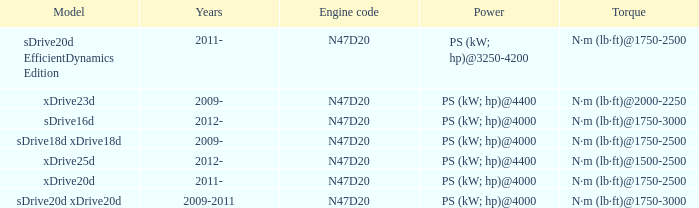What is the engine code of the xdrive23d model? N47D20. 